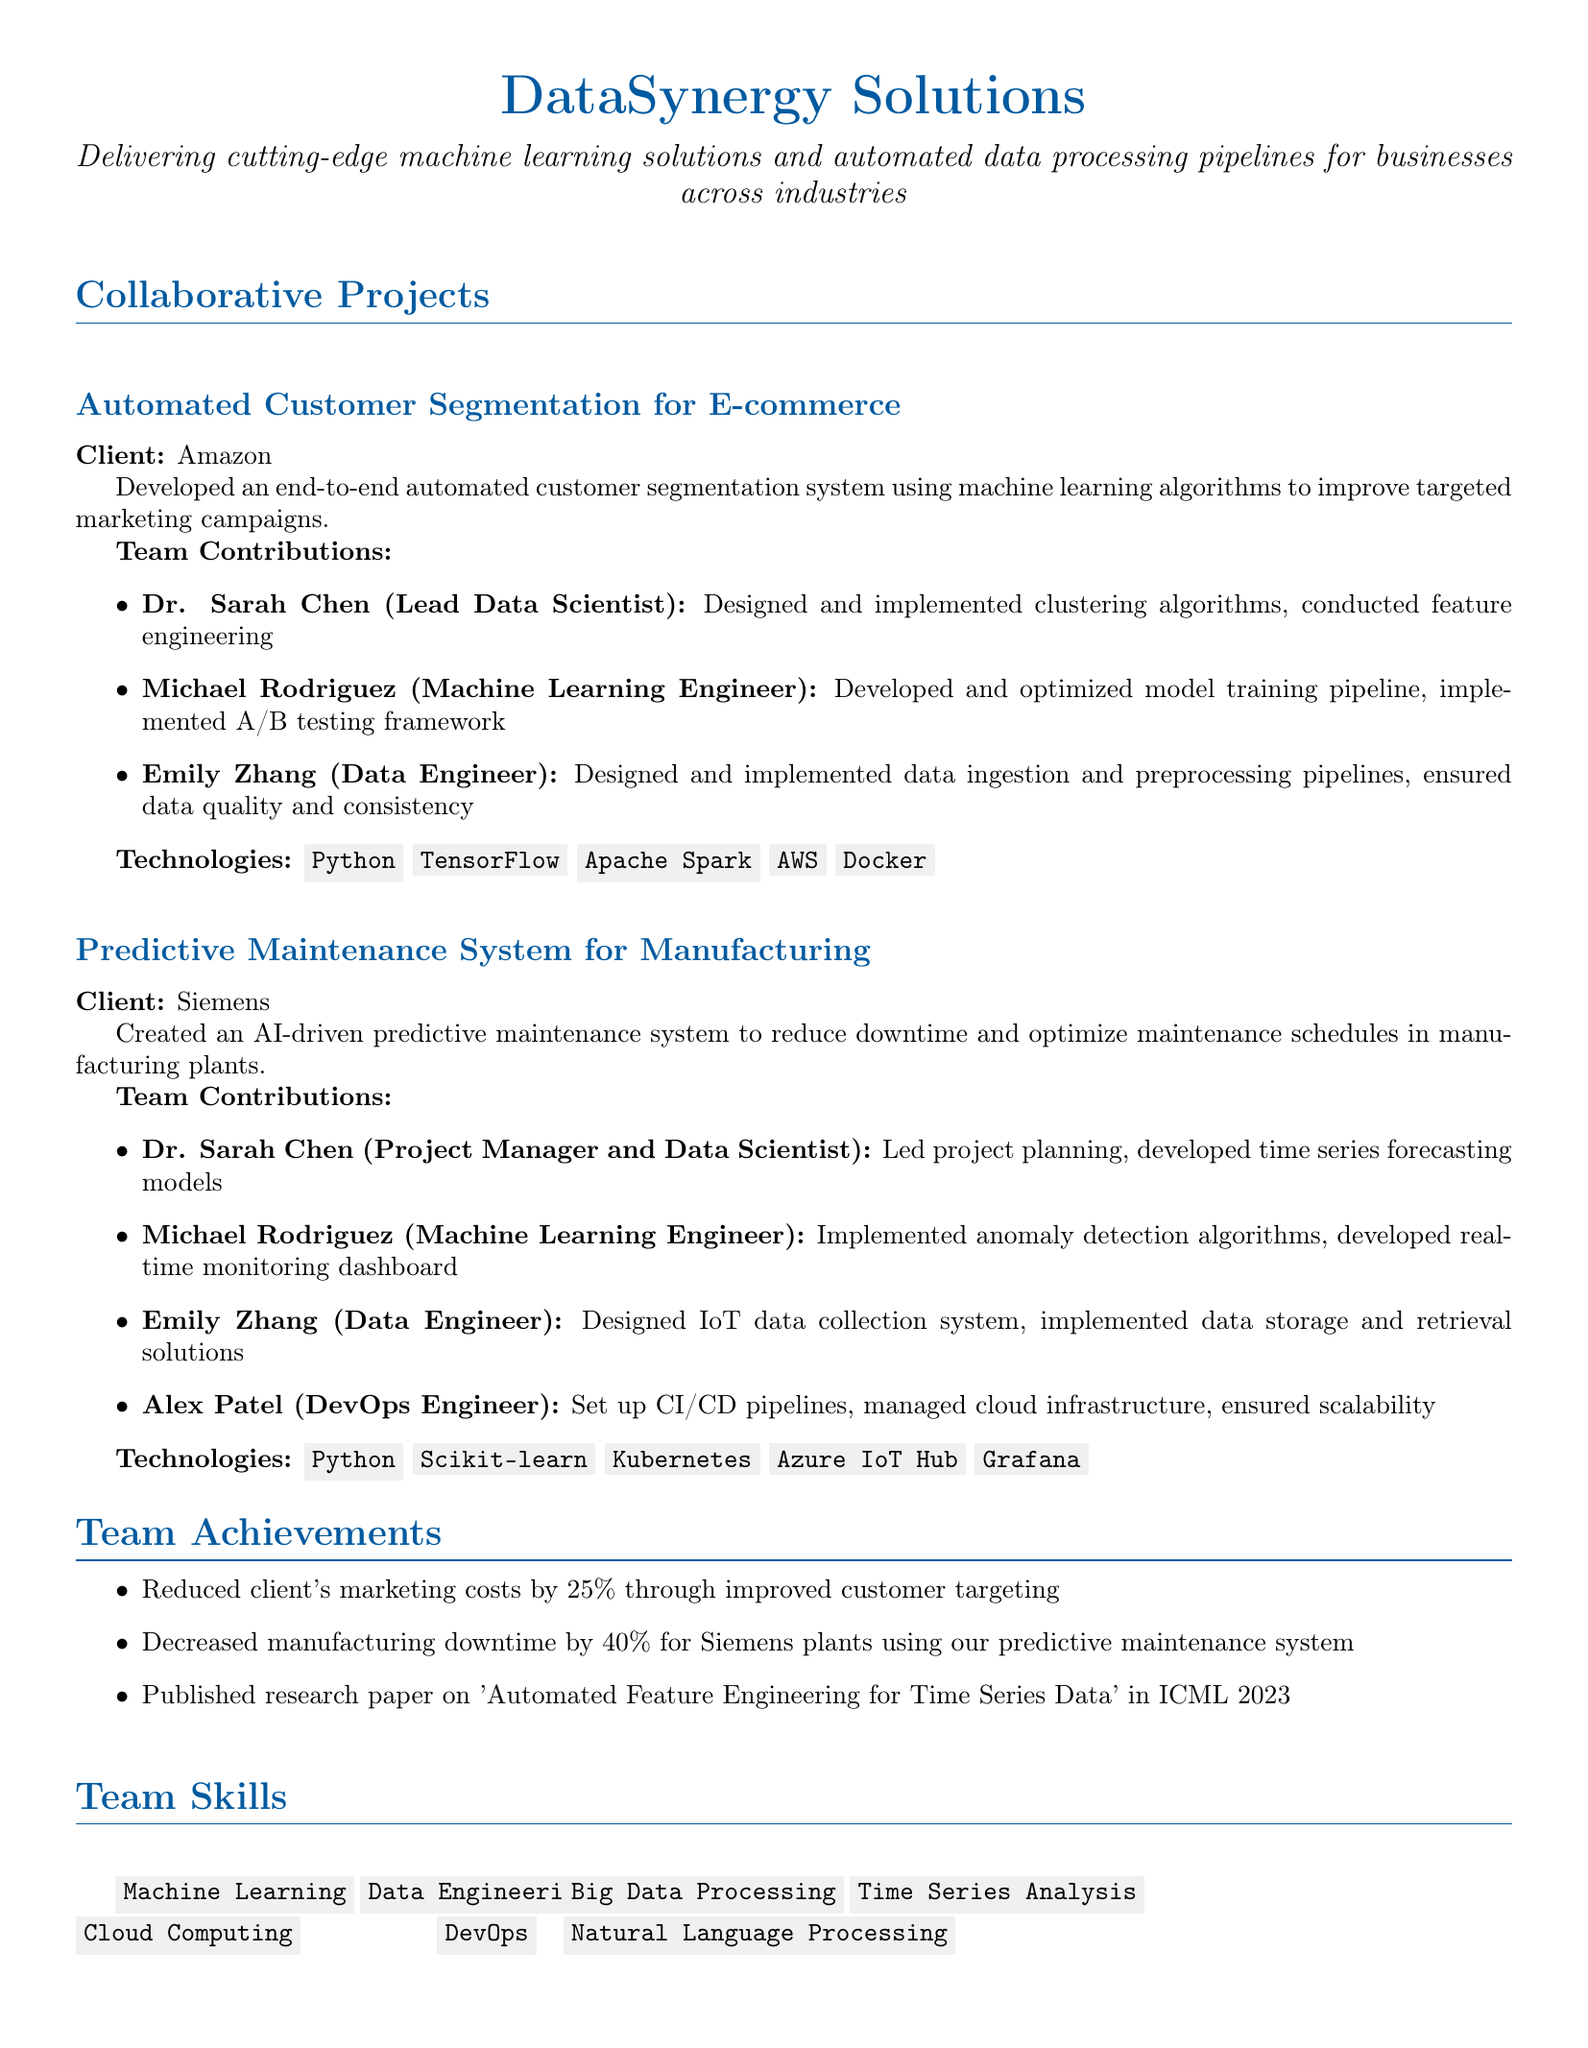What is the name of the team? The document begins with the team's name "DataSynergy Solutions."
Answer: DataSynergy Solutions What was the client for the automated customer segmentation project? The project titled 'Automated Customer Segmentation for E-commerce' identifies Amazon as the client.
Answer: Amazon Who served as the Lead Data Scientist in the Predictive Maintenance System project? The contributions section for the Predictive Maintenance System project indicates Dr. Sarah Chen's role as Project Manager and Data Scientist.
Answer: Dr. Sarah Chen What was the percentage decrease in manufacturing downtime for Siemens plants? The team achievements section states a 40% decrease in manufacturing downtime due to their predictive maintenance system.
Answer: 40% Which technology was used in the Automated Customer Segmentation for E-commerce project? The technologies used in that project include Python, TensorFlow, Apache Spark, AWS, and Docker, as detailed in the project description.
Answer: Python, TensorFlow, Apache Spark, AWS, Docker How many collaborative projects are listed in the document? The document outlines two collaborative projects, 'Automated Customer Segmentation for E-commerce' and 'Predictive Maintenance System for Manufacturing.'
Answer: 2 What accomplishment is mentioned under team achievements related to marketing? The team's achievement section specifies a reduction in marketing costs by 25% as a result of improved customer targeting.
Answer: Reduced client's marketing costs by 25% Who was responsible for developing the real-time monitoring dashboard? Michael Rodriguez is credited in the contributions of the Predictive Maintenance System project for developing the real-time monitoring dashboard.
Answer: Michael Rodriguez What is one skill listed under team skills? The document lists various skills, including Machine Learning, Data Engineering, and Cloud Computing.
Answer: Machine Learning 